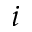Convert formula to latex. <formula><loc_0><loc_0><loc_500><loc_500>i</formula> 